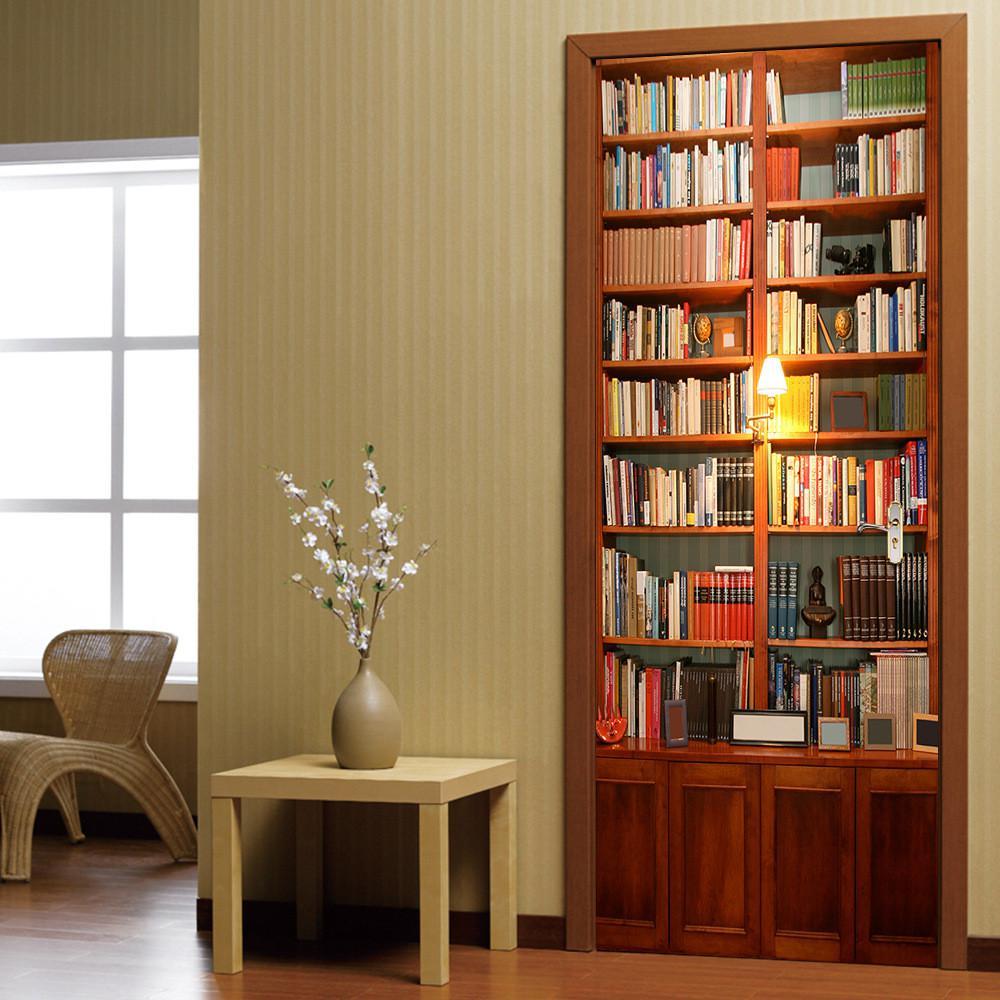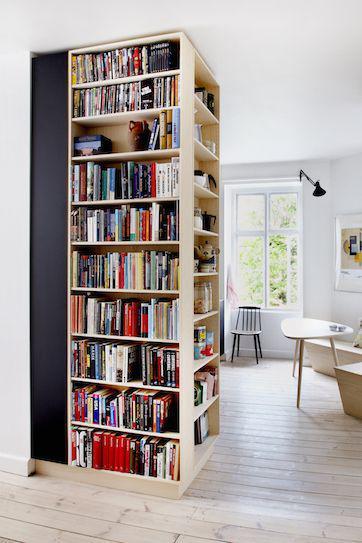The first image is the image on the left, the second image is the image on the right. Examine the images to the left and right. Is the description "One of the bookshelves has wooden cabinet doors at the bottom." accurate? Answer yes or no. Yes. The first image is the image on the left, the second image is the image on the right. For the images displayed, is the sentence "there is a built in bookcase with white molding and molding on half the wall around it" factually correct? Answer yes or no. No. 